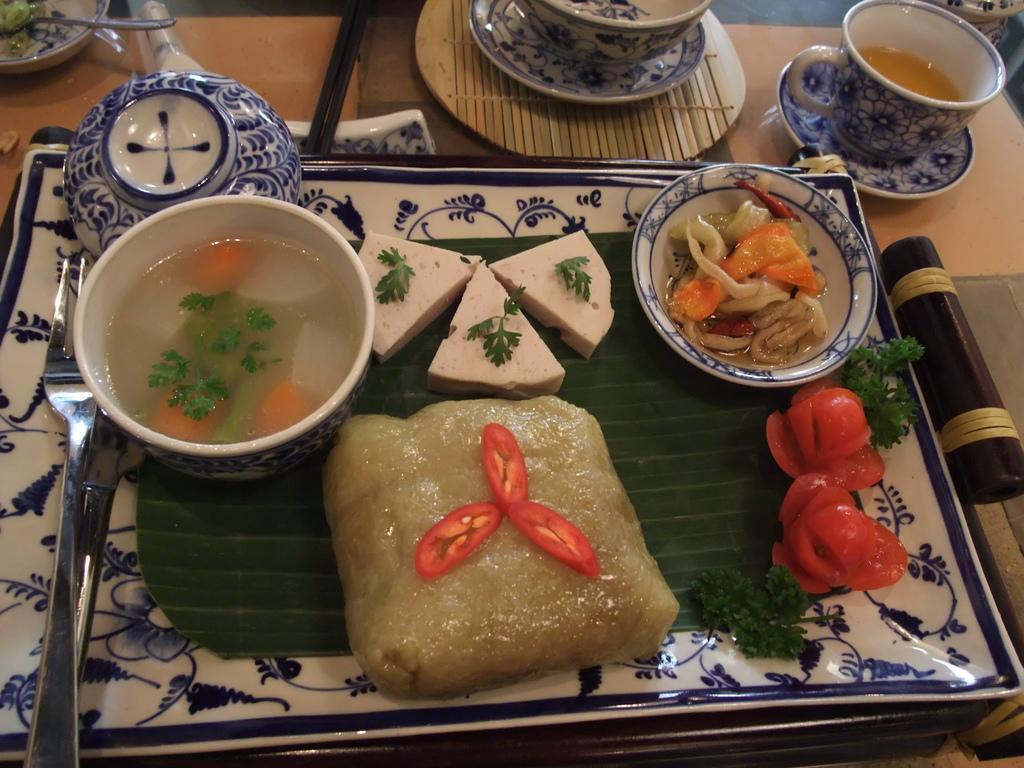In one or two sentences, can you explain what this image depicts? There are sweets arranged, leaves and other fruits pieces arranged on the banana leaf, along with a liquid in a cup and other food items in a saucer. And this leaf on the plate along with a fork, a cup, which is reversed and a knife. This plate is on the table, on which, there are cups and saucers and other objects. 